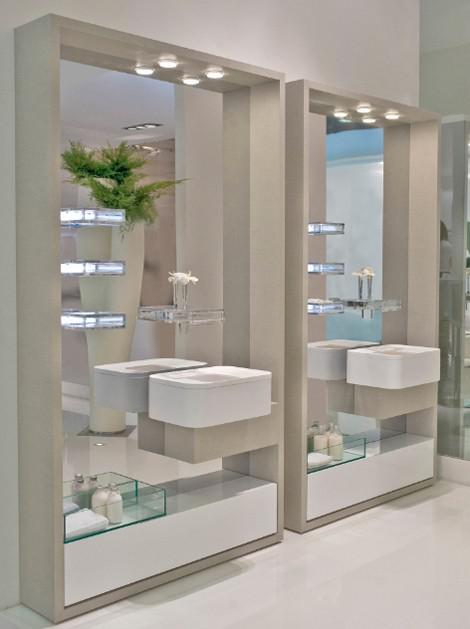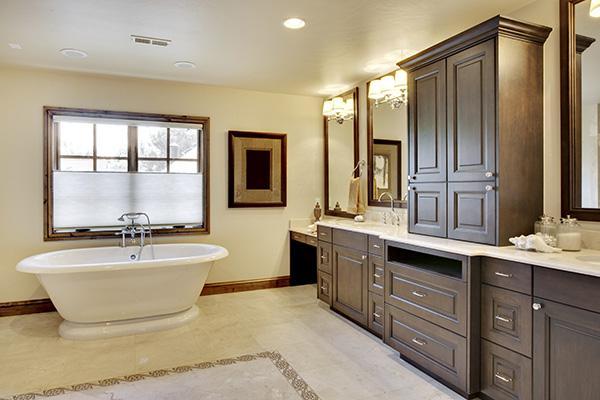The first image is the image on the left, the second image is the image on the right. Examine the images to the left and right. Is the description "Right image shows only one rectangular mirror hanging over only one vanity with one sink, in a room with no bathtub visible." accurate? Answer yes or no. No. The first image is the image on the left, the second image is the image on the right. For the images shown, is this caption "An area with two bathroom sinks and a glass shower unit can be seen in one image, while the other image shows a single sink and surrounding cabinetry." true? Answer yes or no. No. 